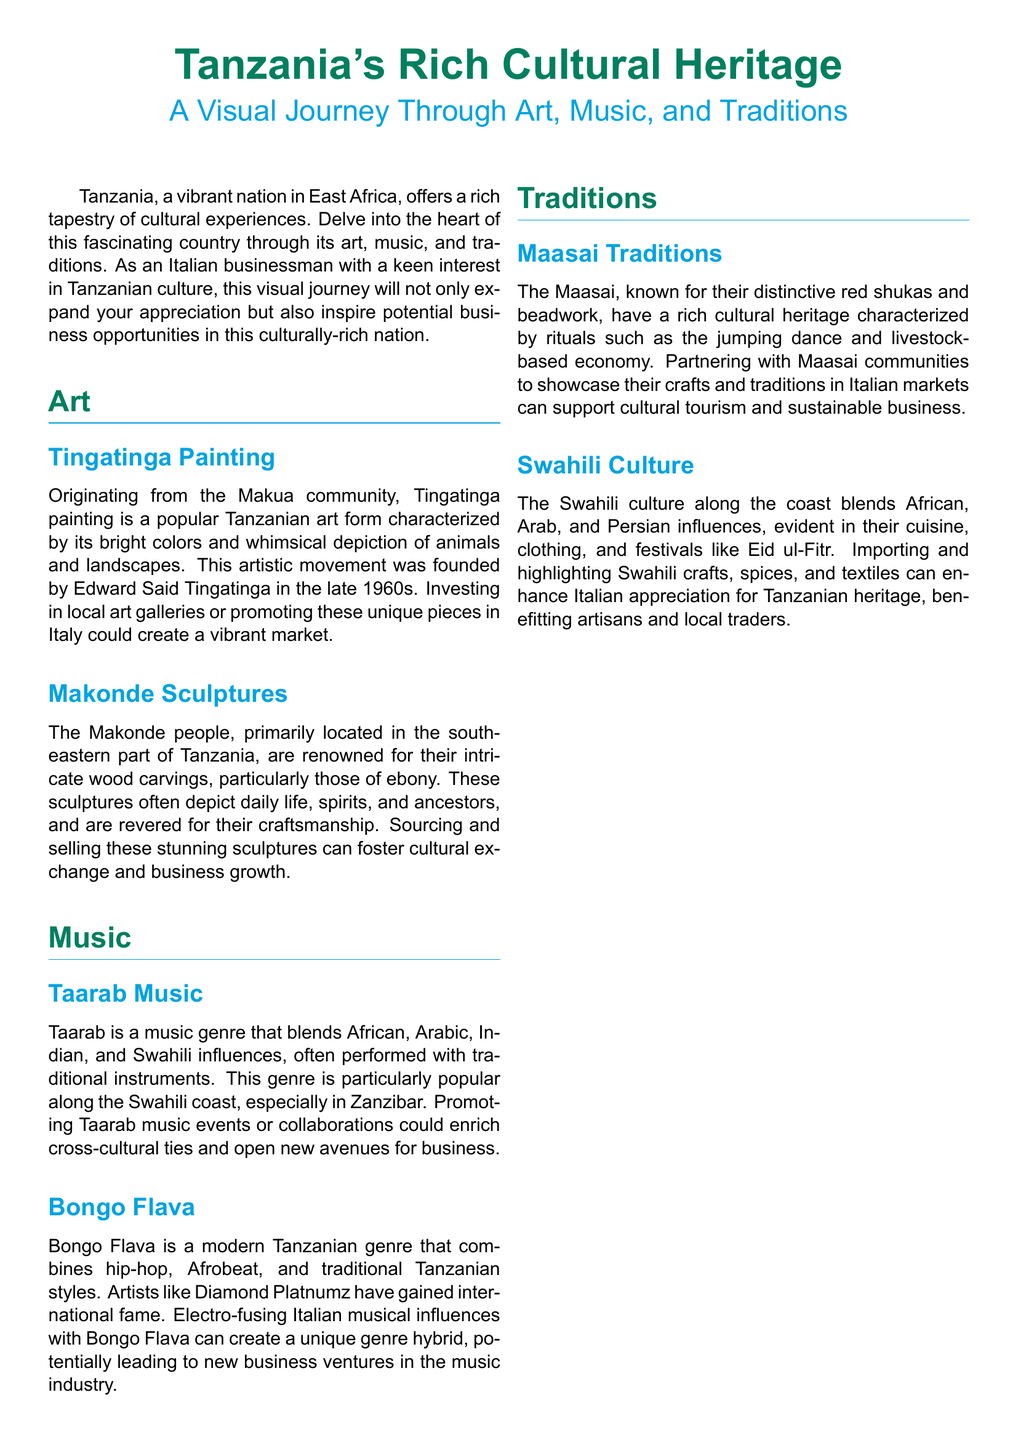what is the main focus of the document? The main focus of the document is to explore Tanzania's rich cultural heritage through various aspects such as art, music, and traditions.
Answer: Tanzania's rich cultural heritage who is the founder of Tingatinga painting? Tingatinga painting was founded by Edward Said Tingatinga in the late 1960s.
Answer: Edward Said Tingatinga what is a notable characteristic of Makonde sculptures? Makonde sculptures are characterized by their intricate wood carvings, particularly those of ebony.
Answer: Intricate wood carvings what music genre blends African, Arabic, Indian, and Swahili influences? Taarab is the music genre that blends these influences.
Answer: Taarab which Tanzanian music genre is compared to hip-hop and Afrobeat? Bongo Flava is the Tanzanian music genre that combines these styles.
Answer: Bongo Flava what color are the traditional garments of the Maasai? The traditional garments of the Maasai are typically red shukas.
Answer: Red shukas which festival is mentioned in relation to Swahili culture? Eid ul-Fitr is the festival mentioned in association with Swahili culture.
Answer: Eid ul-Fitr what type of opportunities does the document suggest Tanzania offers? The document suggests that Tanzania offers opportunities for personal and business growth.
Answer: Personal and business growth what is the recommended action for promoting Taarab music? The document recommends promoting Taarab music events or collaborations.
Answer: Promoting Taarab music events 